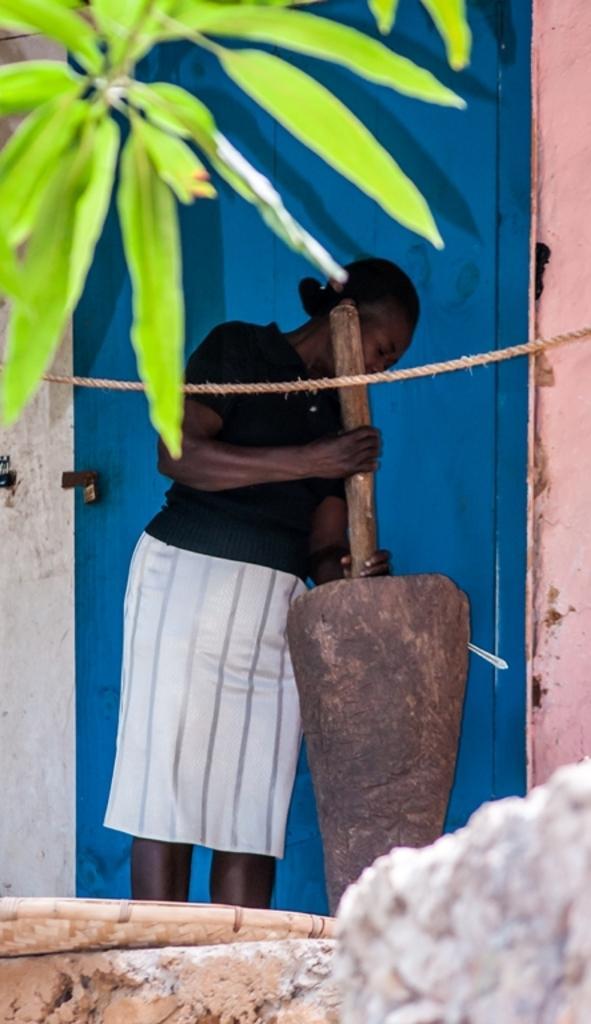Describe this image in one or two sentences. In this image there is one women is standing in middle of this image is holding an object and there is a blue color door in the background. There are some leaves on the top left side of this image. 